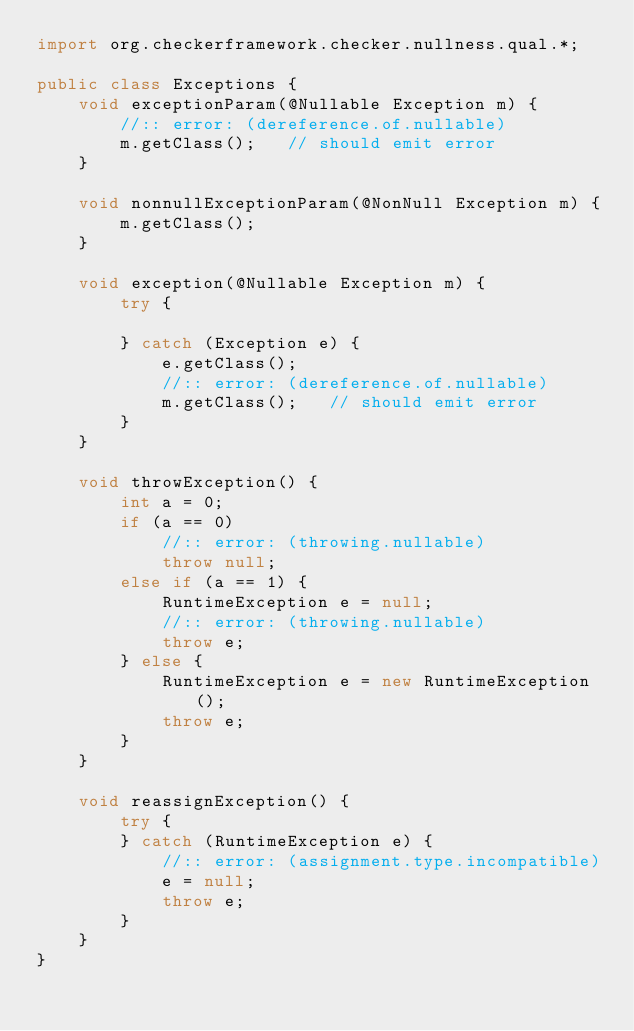Convert code to text. <code><loc_0><loc_0><loc_500><loc_500><_Java_>import org.checkerframework.checker.nullness.qual.*;

public class Exceptions {
    void exceptionParam(@Nullable Exception m) {
        //:: error: (dereference.of.nullable)
        m.getClass();   // should emit error
    }

    void nonnullExceptionParam(@NonNull Exception m) {
        m.getClass();
    }

    void exception(@Nullable Exception m) {
        try {

        } catch (Exception e) {
            e.getClass();
            //:: error: (dereference.of.nullable)
            m.getClass();   // should emit error
        }
    }

    void throwException() {
        int a = 0;
        if (a == 0)
            //:: error: (throwing.nullable)
            throw null;
        else if (a == 1) {
            RuntimeException e = null;
            //:: error: (throwing.nullable)
            throw e;
        } else {
            RuntimeException e = new RuntimeException();
            throw e;
        }
    }

    void reassignException() {
        try {
        } catch (RuntimeException e) {
            //:: error: (assignment.type.incompatible)
            e = null;
            throw e;
        }
    }
}
</code> 